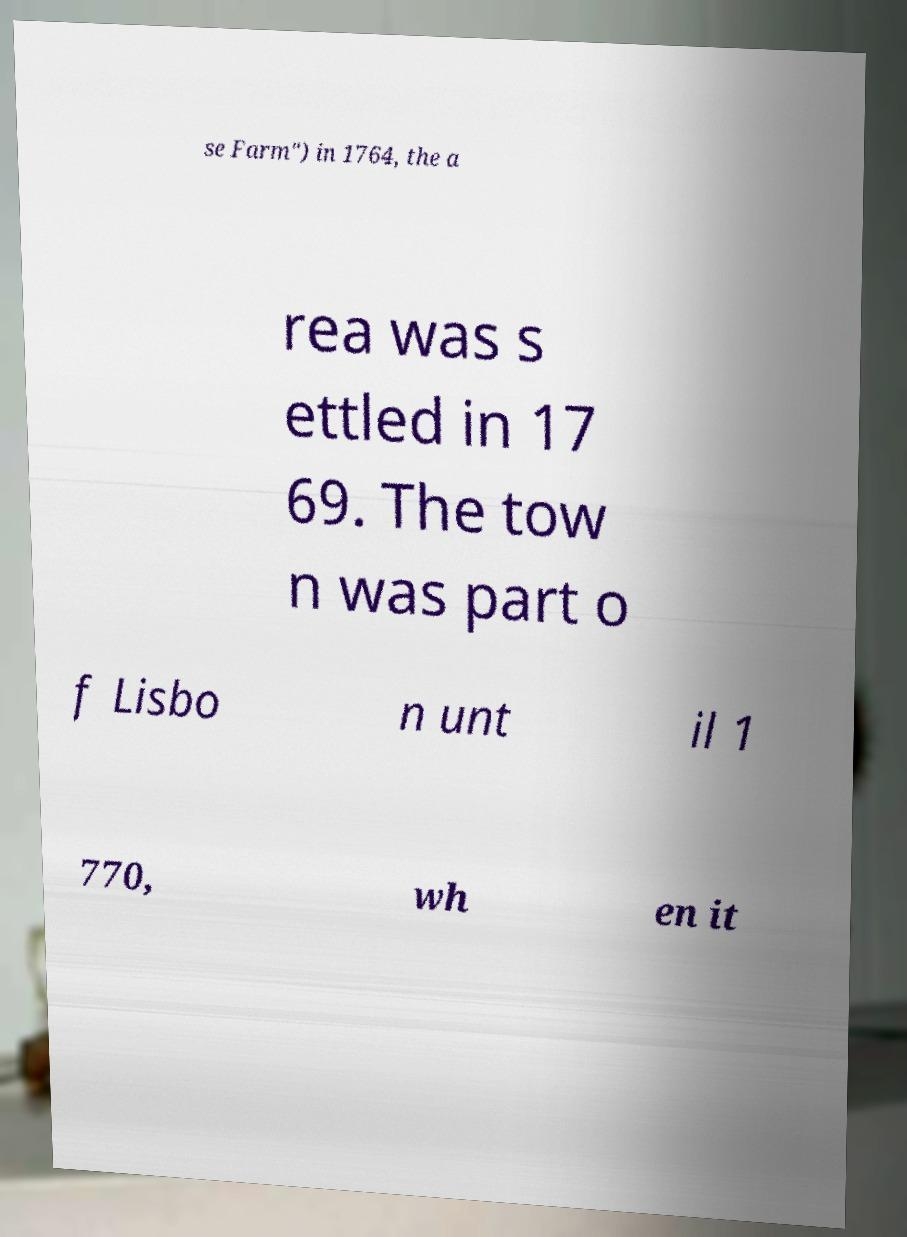Please identify and transcribe the text found in this image. se Farm") in 1764, the a rea was s ettled in 17 69. The tow n was part o f Lisbo n unt il 1 770, wh en it 